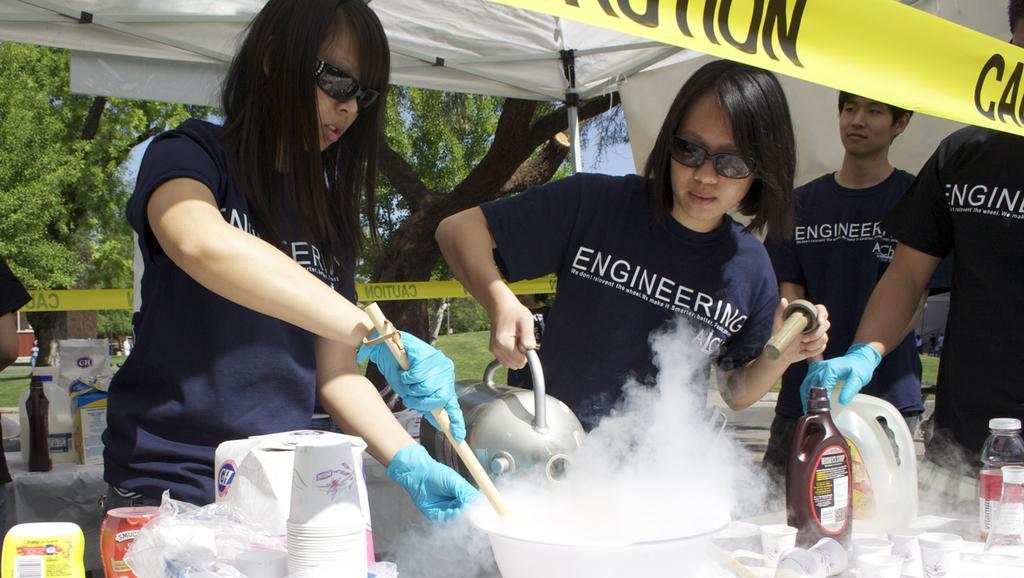Can you describe this image briefly? In this picture we can see few people are under the tent and they are preparing some thing which is placed on the table, side we can see some objects are placed on the table, behind we can see trees, grass and also we can see one more table on which we can see some objects are placed. 